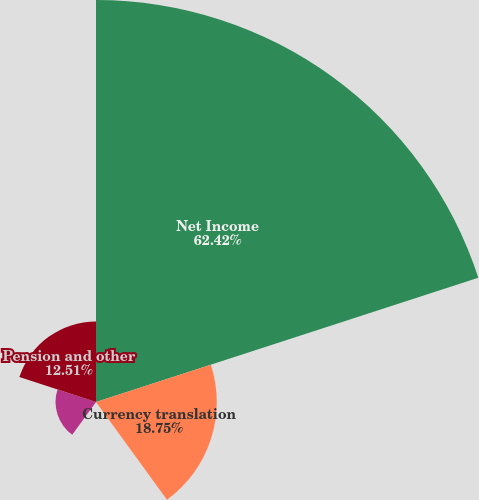Convert chart to OTSL. <chart><loc_0><loc_0><loc_500><loc_500><pie_chart><fcel>Net Income<fcel>Currency translation<fcel>Unrealized gains on<fcel>Unrealized gains (losses) on<fcel>Pension and other<nl><fcel>62.42%<fcel>18.75%<fcel>0.04%<fcel>6.28%<fcel>12.51%<nl></chart> 